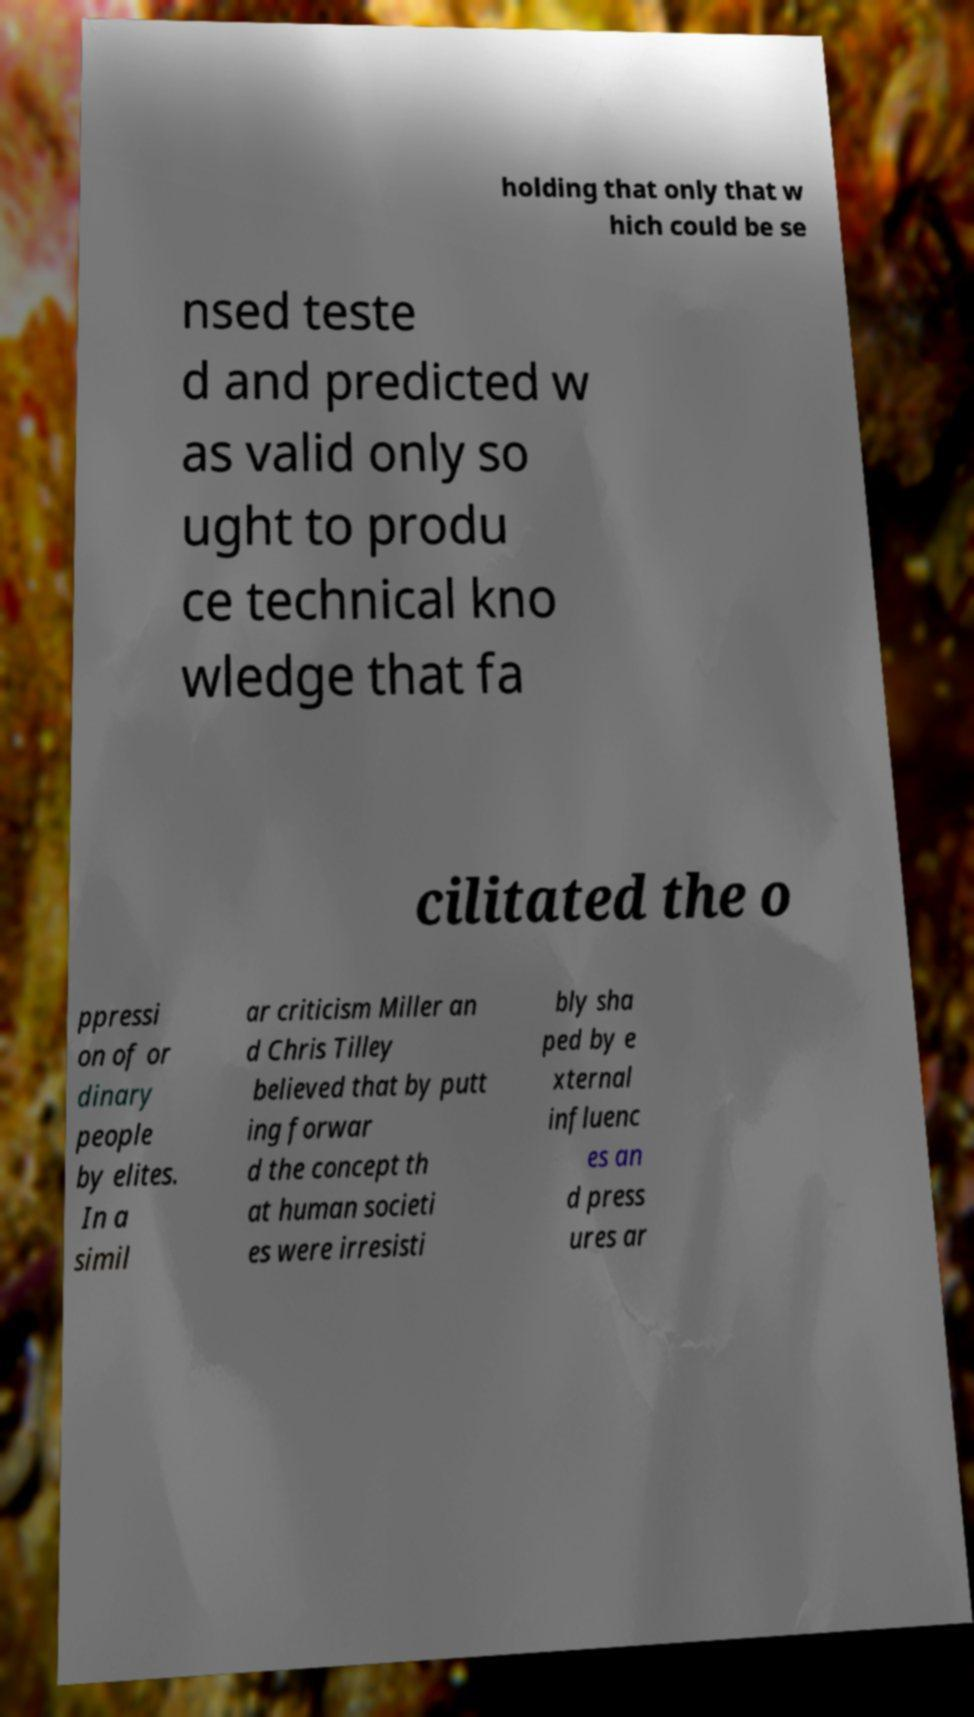Could you assist in decoding the text presented in this image and type it out clearly? holding that only that w hich could be se nsed teste d and predicted w as valid only so ught to produ ce technical kno wledge that fa cilitated the o ppressi on of or dinary people by elites. In a simil ar criticism Miller an d Chris Tilley believed that by putt ing forwar d the concept th at human societi es were irresisti bly sha ped by e xternal influenc es an d press ures ar 